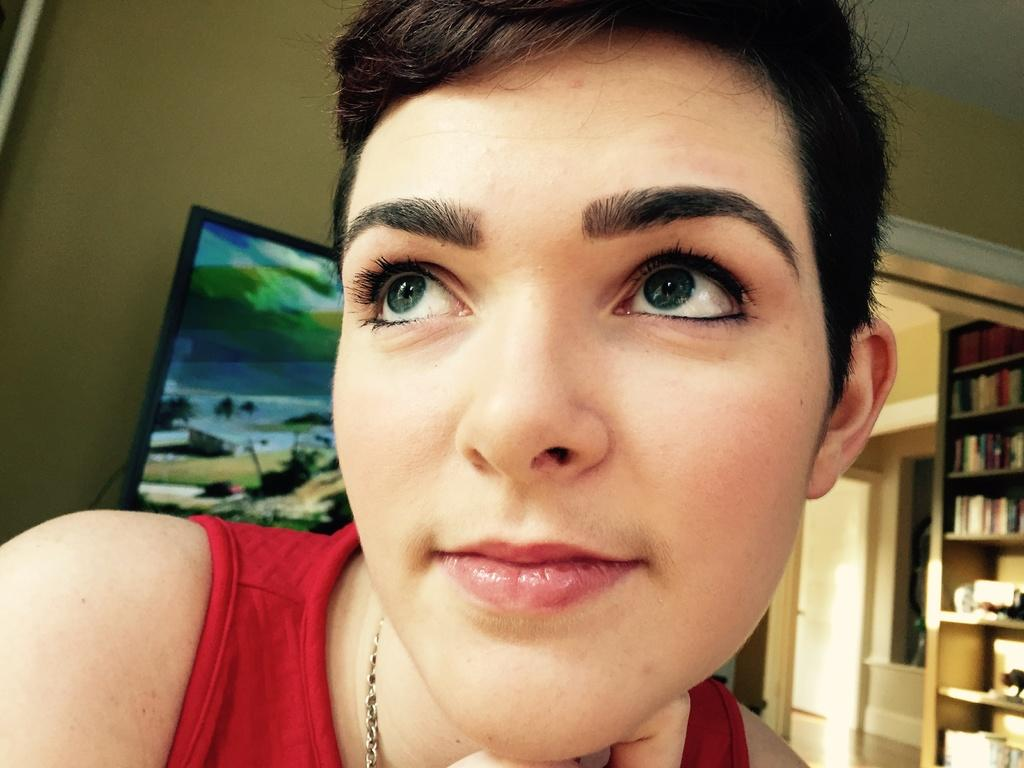What is present in the image? There is a person in the image. What can be seen in the background of the image? There is a wall, a screen, a rack, and books in the background of the image. What type of cover is the person wearing in the image? There is no mention of a cover or any clothing worn by the person in the image. What activity is the person engaged in with their fangs in the image? There is no mention of fangs or any activity involving them in the image. 